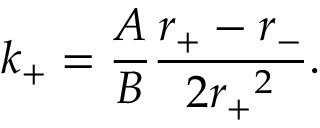<formula> <loc_0><loc_0><loc_500><loc_500>k _ { + } = \frac { A } { B } \frac { r _ { + } - r _ { - } } { 2 { r _ { + } } ^ { 2 } } .</formula> 